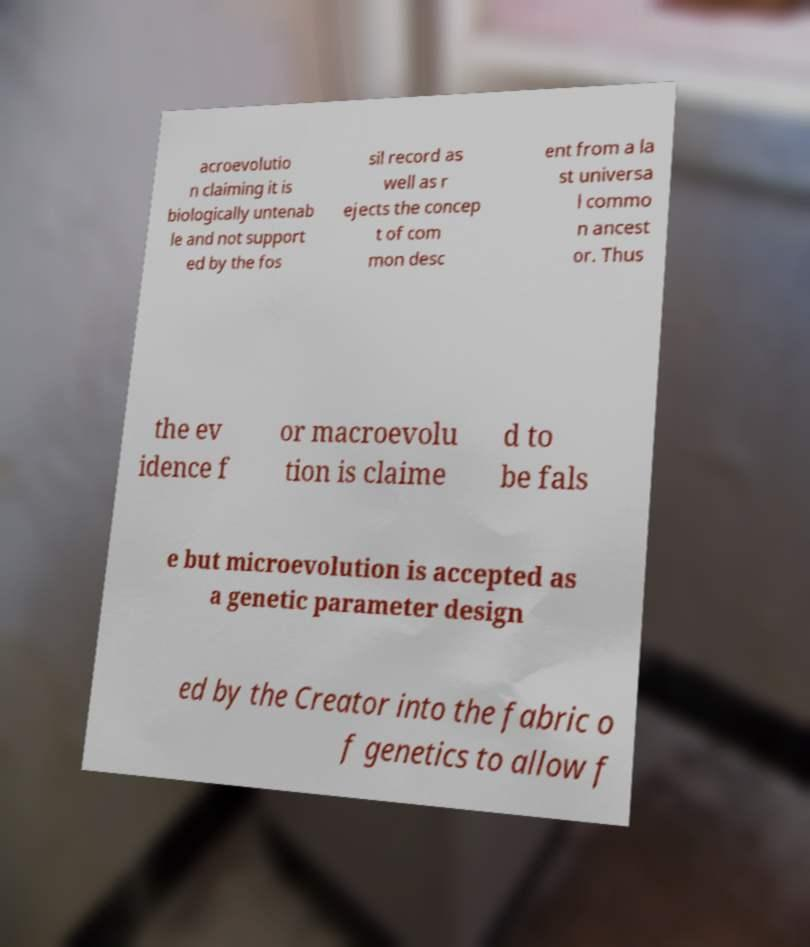Could you assist in decoding the text presented in this image and type it out clearly? acroevolutio n claiming it is biologically untenab le and not support ed by the fos sil record as well as r ejects the concep t of com mon desc ent from a la st universa l commo n ancest or. Thus the ev idence f or macroevolu tion is claime d to be fals e but microevolution is accepted as a genetic parameter design ed by the Creator into the fabric o f genetics to allow f 